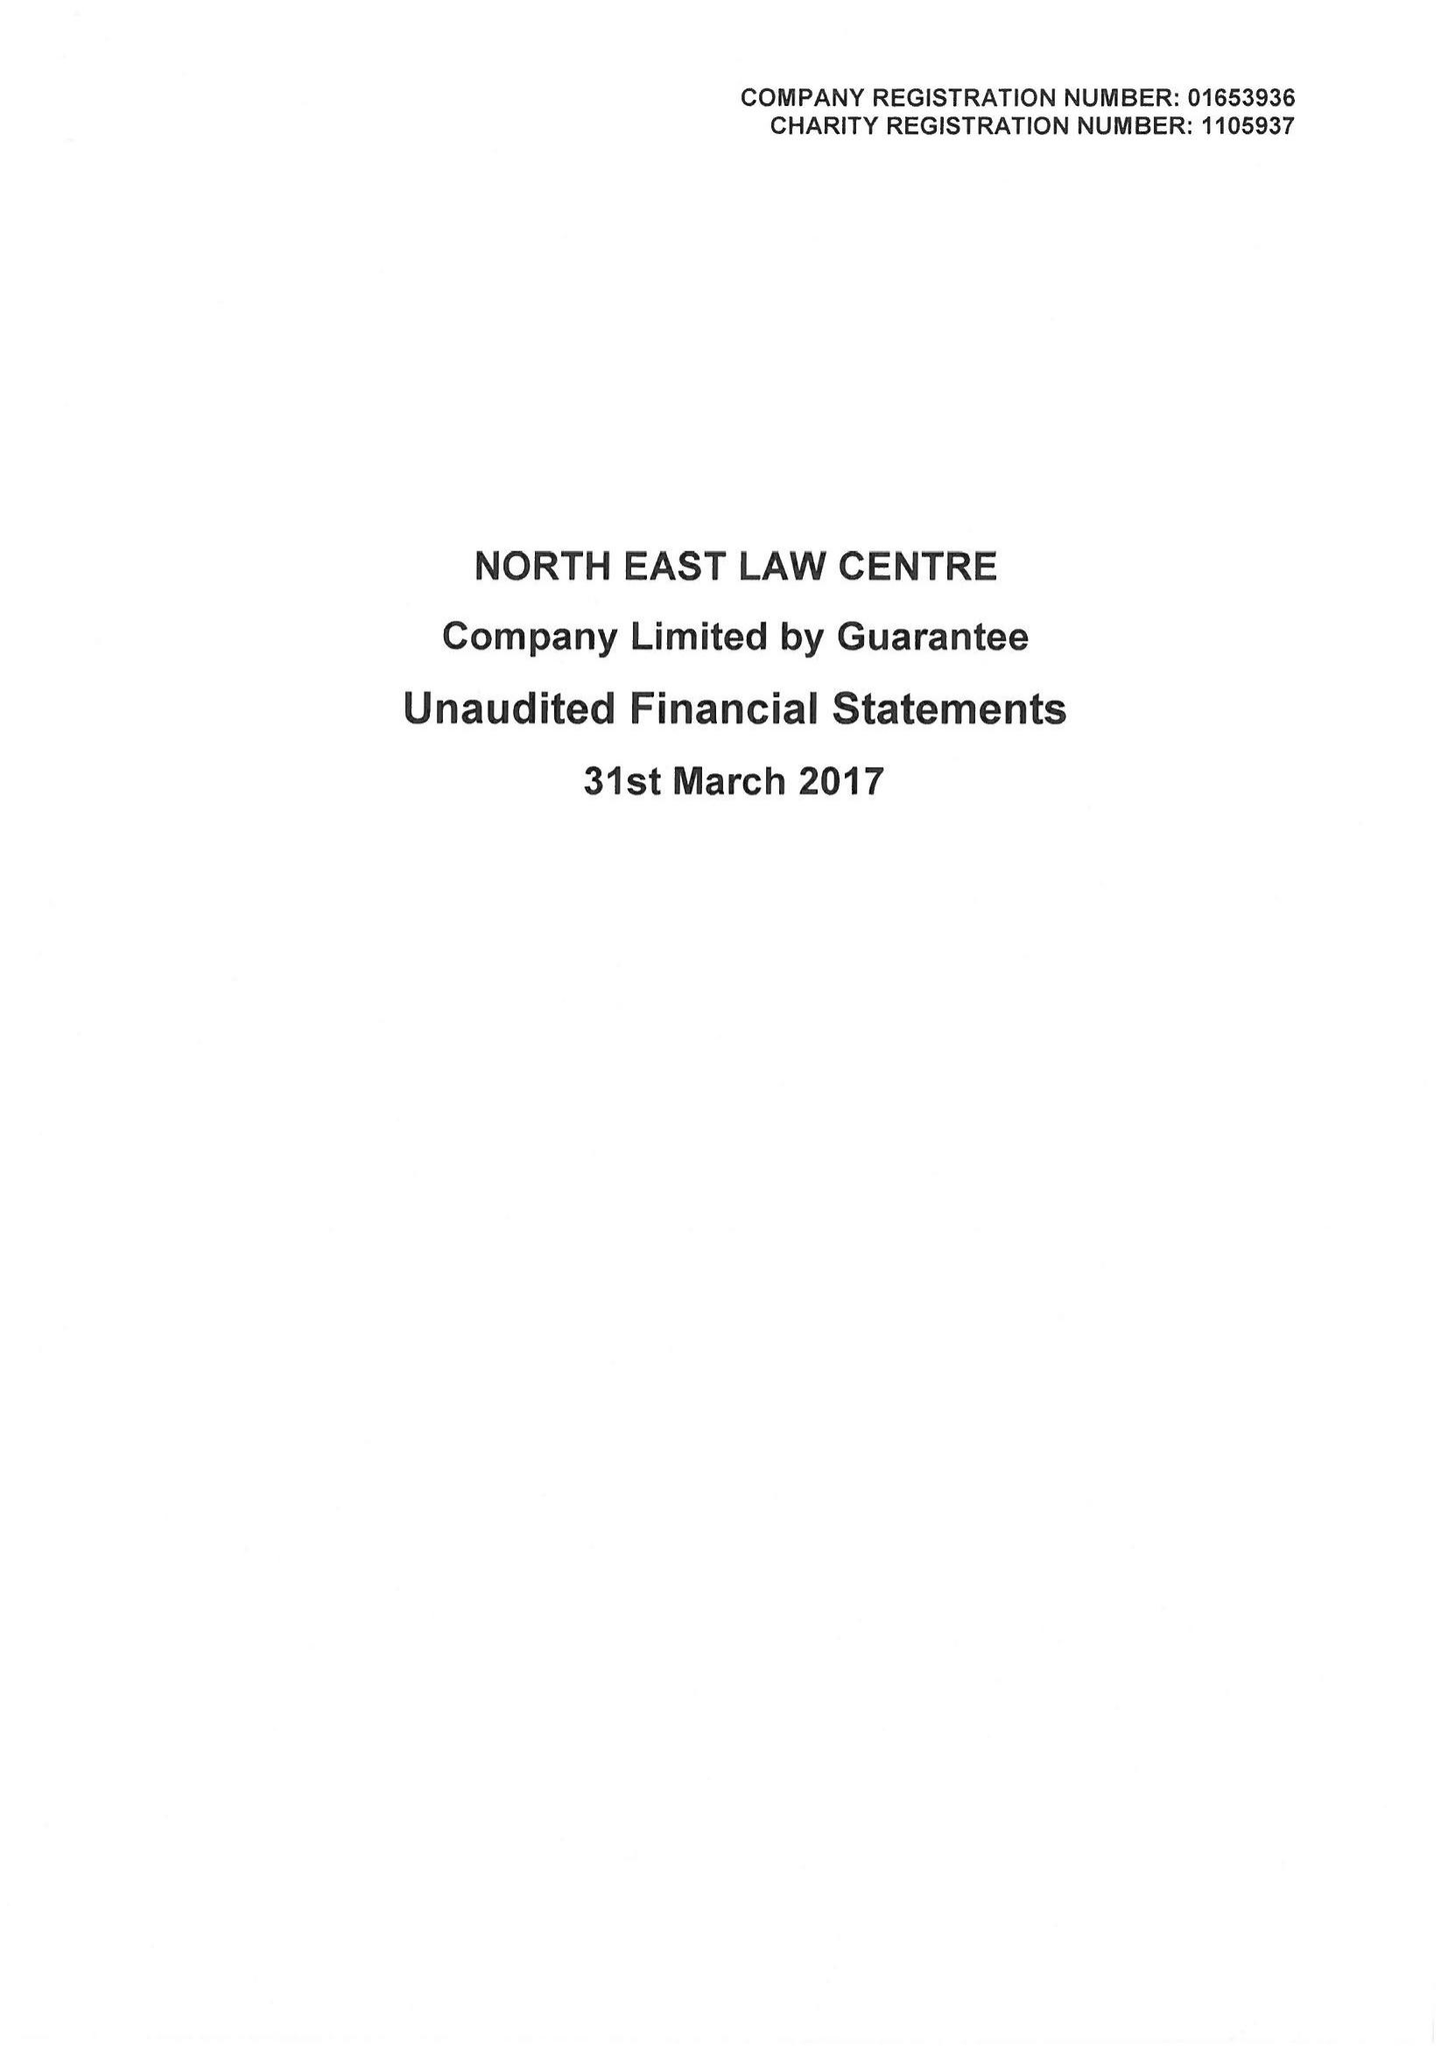What is the value for the charity_name?
Answer the question using a single word or phrase. North East Law Centre 